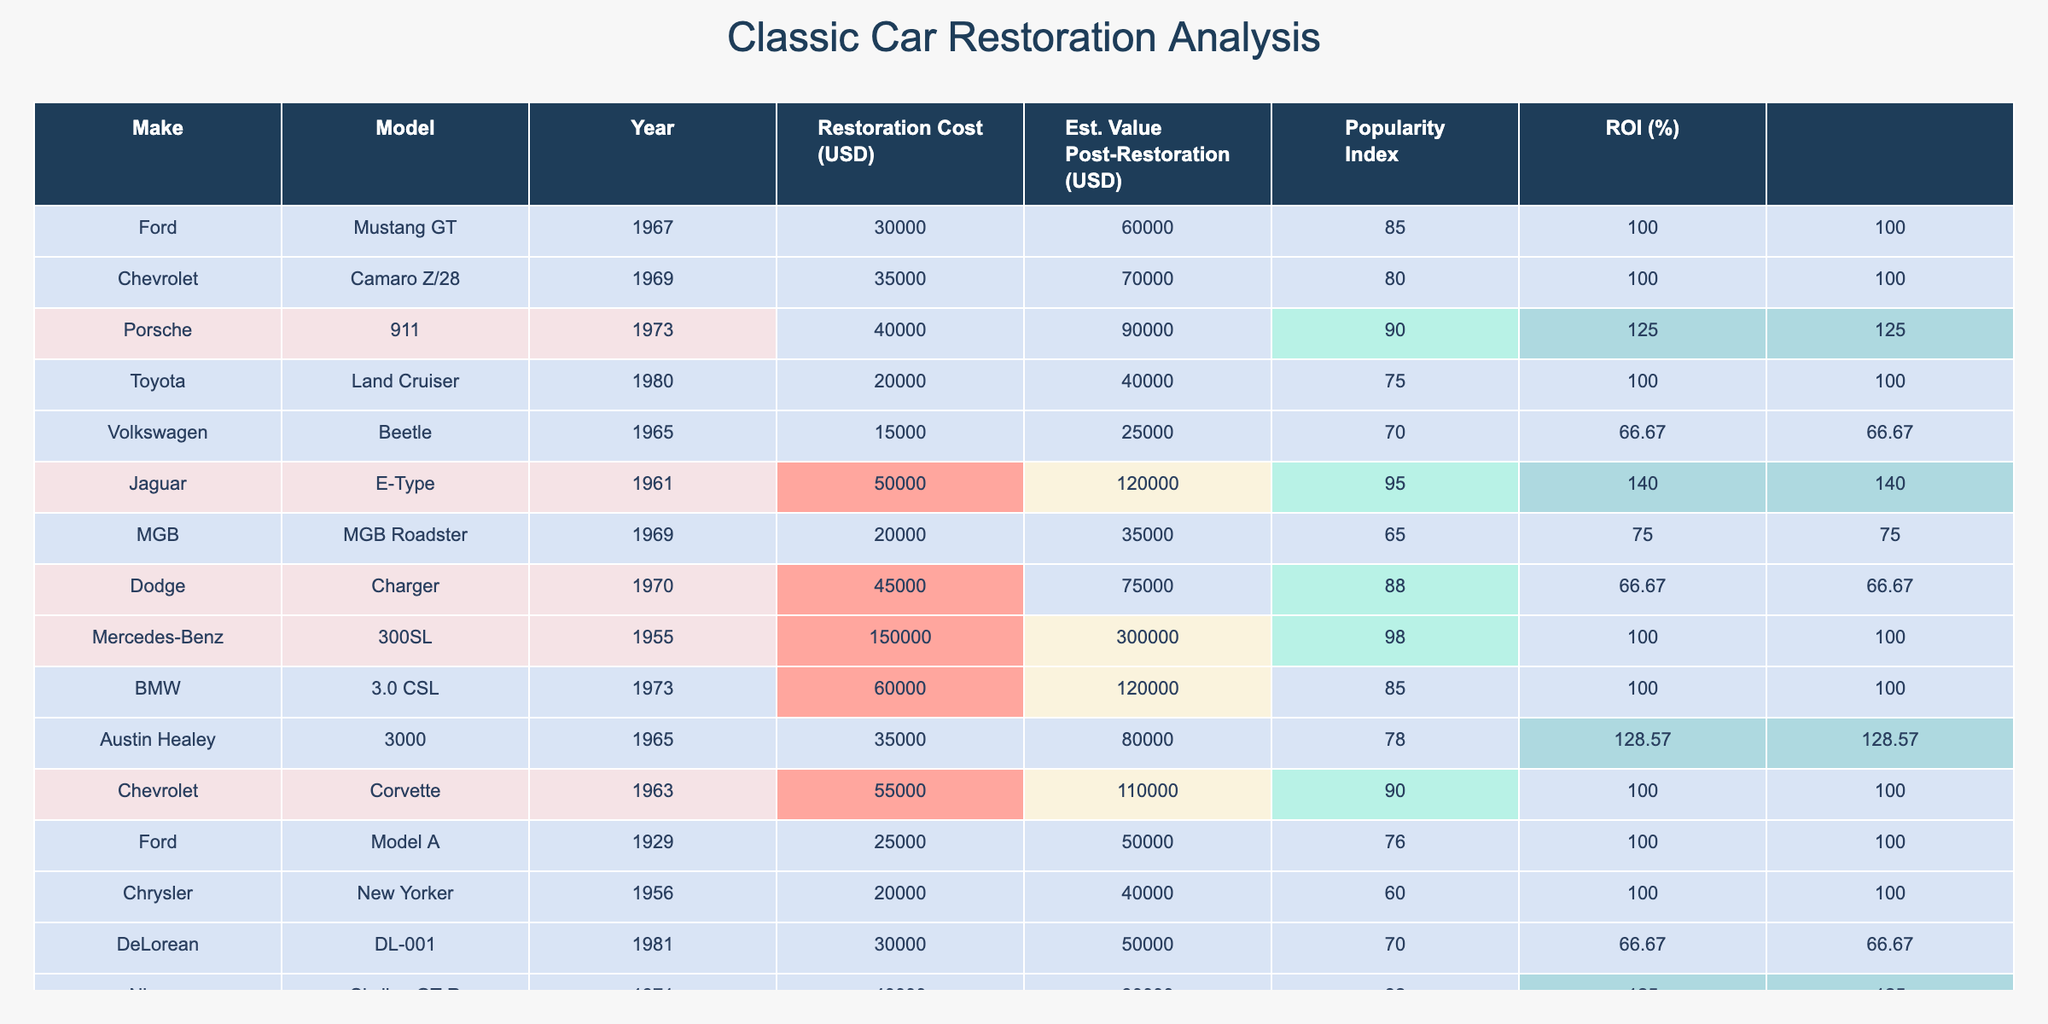What is the restoration cost of the Porsche 911? The table shows a specific row for the Porsche 911 with a restoration cost directly listed. In the column 'Restoration Cost (USD)', the value is given as 40000.
Answer: 40000 Which car has the highest estimated value post-restoration? By analyzing the 'Estimated Value Post-Restoration (USD)' column, the highest value listed is for the Mercedes-Benz 300SL at 300000, making it the car with the highest estimated value.
Answer: 300000 Calculate the average restoration cost of all the cars listed in the table. Adding all the restoration costs: 30000 + 35000 + 40000 + 20000 + 15000 + 50000 + 20000 + 45000 + 150000 + 60000 + 35000 + 25000 + 20000 + 30000 + 40000 =  452500. Dividing by the number of cars (15), the average restoration cost is 452500/15 = 30166.67.
Answer: 30166.67 Is the Jaguar E-Type restoration cost more than the average cost of all cars? Since we found the average restoration cost to be 30166.67, we check the Jaguar E-Type's restoration cost of 50000. As 50000 is greater than 30166.67, it confirms the statement to be true.
Answer: Yes What is the total estimated value post-restoration for all Ford models? The Ford models listed are the Mustang GT and Model A. Their values are 60000 and 50000 respectively. Adding these gives 60000 + 50000 = 110000 for the total estimated value post-restoration of Ford models.
Answer: 110000 Which car has the highest popularity index, and what is its value? By reviewing the 'Popularity Index' column, we see that the Mercedes-Benz 300SL has the highest index of 98. We reference its estimated value post-restoration, which is 300000.
Answer: Mercedes-Benz 300SL, 300000 What is the ROI for the Chevrolet Camaro Z/28? To find the ROI, we apply the formula (Estimated Value Post-Restoration - Restoration Cost) / Restoration Cost * 100. For the Camaro Z/28, it is (70000 - 35000) / 35000 * 100 = 100%.
Answer: 100 Are there any cars with a restoration cost below 20000? Checking the restoration costs, the lowest listed is the Volkswagen Beetle at 15000, which is below 20000. Therefore, the statement is confirmed to be true.
Answer: Yes How many cars have a restoration cost exceeding 40000? Filtering the table, we identify the cars with restoration costs above 40000: Mustang GT, Camaro Z/28, Porsche 911, Dodge Charger, BMW 3.0 CSL, Chevrolet Corvette, and Mercedes-Benz 300SL, making a total of 7 cars.
Answer: 7 